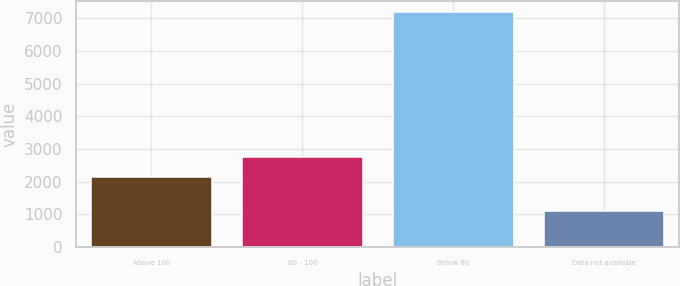Convert chart. <chart><loc_0><loc_0><loc_500><loc_500><bar_chart><fcel>Above 100<fcel>80 - 100<fcel>Below 80<fcel>Data not available<nl><fcel>2157<fcel>2763.4<fcel>7180<fcel>1116<nl></chart> 